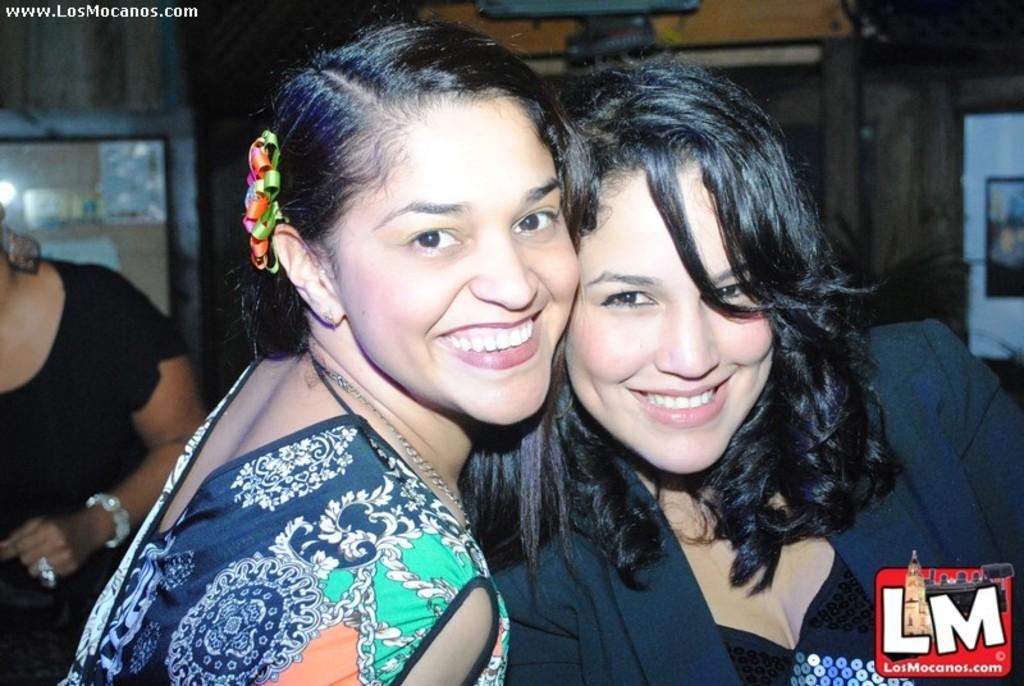Who is present in the image? There are women in the image. What is the facial expression of the women? The women are smiling. Can you describe the background of the image? There is a woman in the background of the image, and objects are arranged in cupboards. Are there any fairies visible in the image? No, there are no fairies present in the image. What is the end result of the women's actions in the image? The image does not depict any actions or events that have a specific end result. --- Facts: 1. There is a car in the image. 2. The car is red. 3. The car has four wheels. 4. There is a road in the image. 5. The road is paved. Absurd Topics: ocean, birdhouse, dinosaur Conversation: What is the main subject of the image? The main subject of the image is a car. What color is the car? The car is red. How many wheels does the car have? The car has four wheels. What is the surface of the road in the image? The road is paved. Reasoning: Let's think step by step in order to produce the conversation. We start by identifying the main subject in the image, which is the car. Then, we describe the car's color and the number of wheels it has. Finally, we expand the conversation to include details about the road in the image, focusing on its surface. Absurd Question/Answer: Can you see any ocean waves in the image? No, there is no ocean or ocean waves present in the image. Is there a birdhouse on top of the car in the image? No, there is no birdhouse present in the image. 